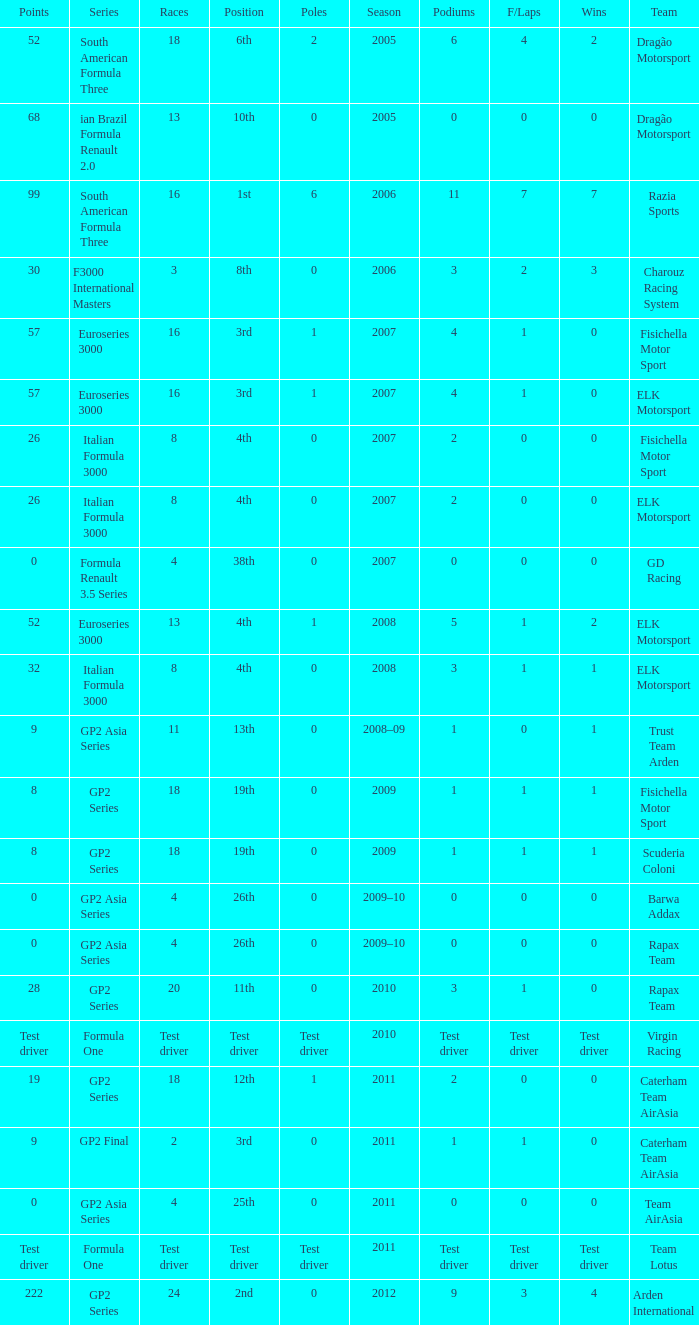How many races did he do in the year he had 8 points? 18, 18. 